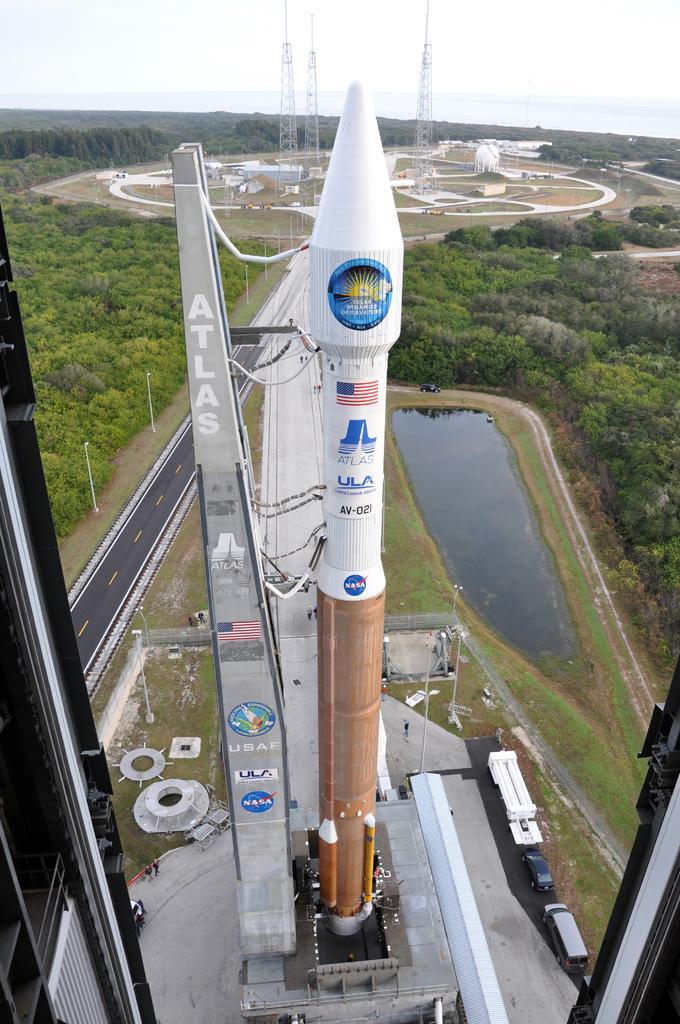How would you summarize this image in a sentence or two? In this picture there is a rocket in the center of the image, there are vehicles, grassland, and water at the bottom side of the image, there are towers and trees in the background area of the image. 